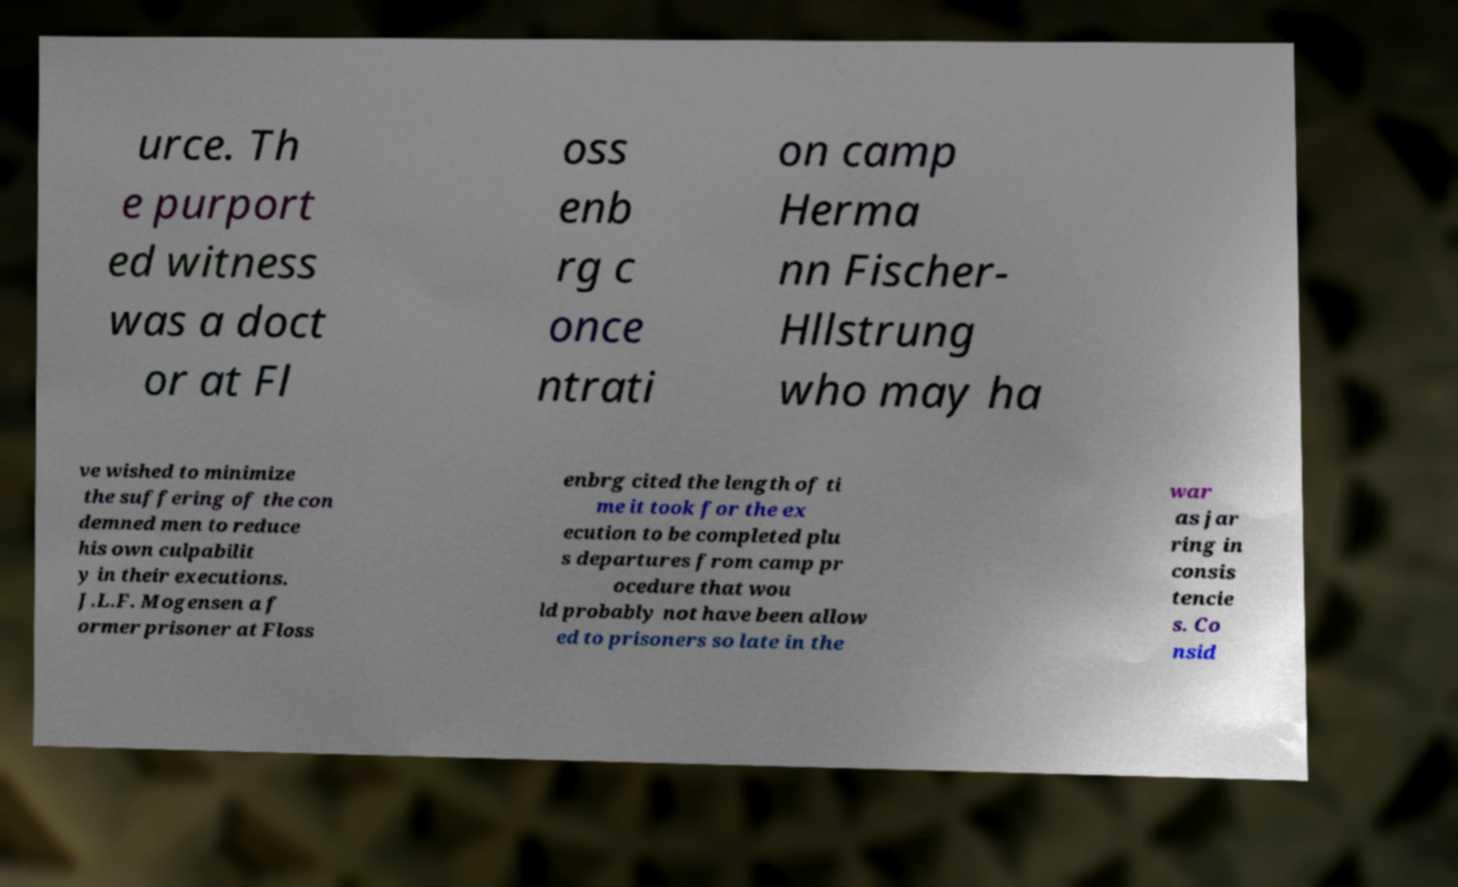Can you accurately transcribe the text from the provided image for me? urce. Th e purport ed witness was a doct or at Fl oss enb rg c once ntrati on camp Herma nn Fischer- Hllstrung who may ha ve wished to minimize the suffering of the con demned men to reduce his own culpabilit y in their executions. J.L.F. Mogensen a f ormer prisoner at Floss enbrg cited the length of ti me it took for the ex ecution to be completed plu s departures from camp pr ocedure that wou ld probably not have been allow ed to prisoners so late in the war as jar ring in consis tencie s. Co nsid 